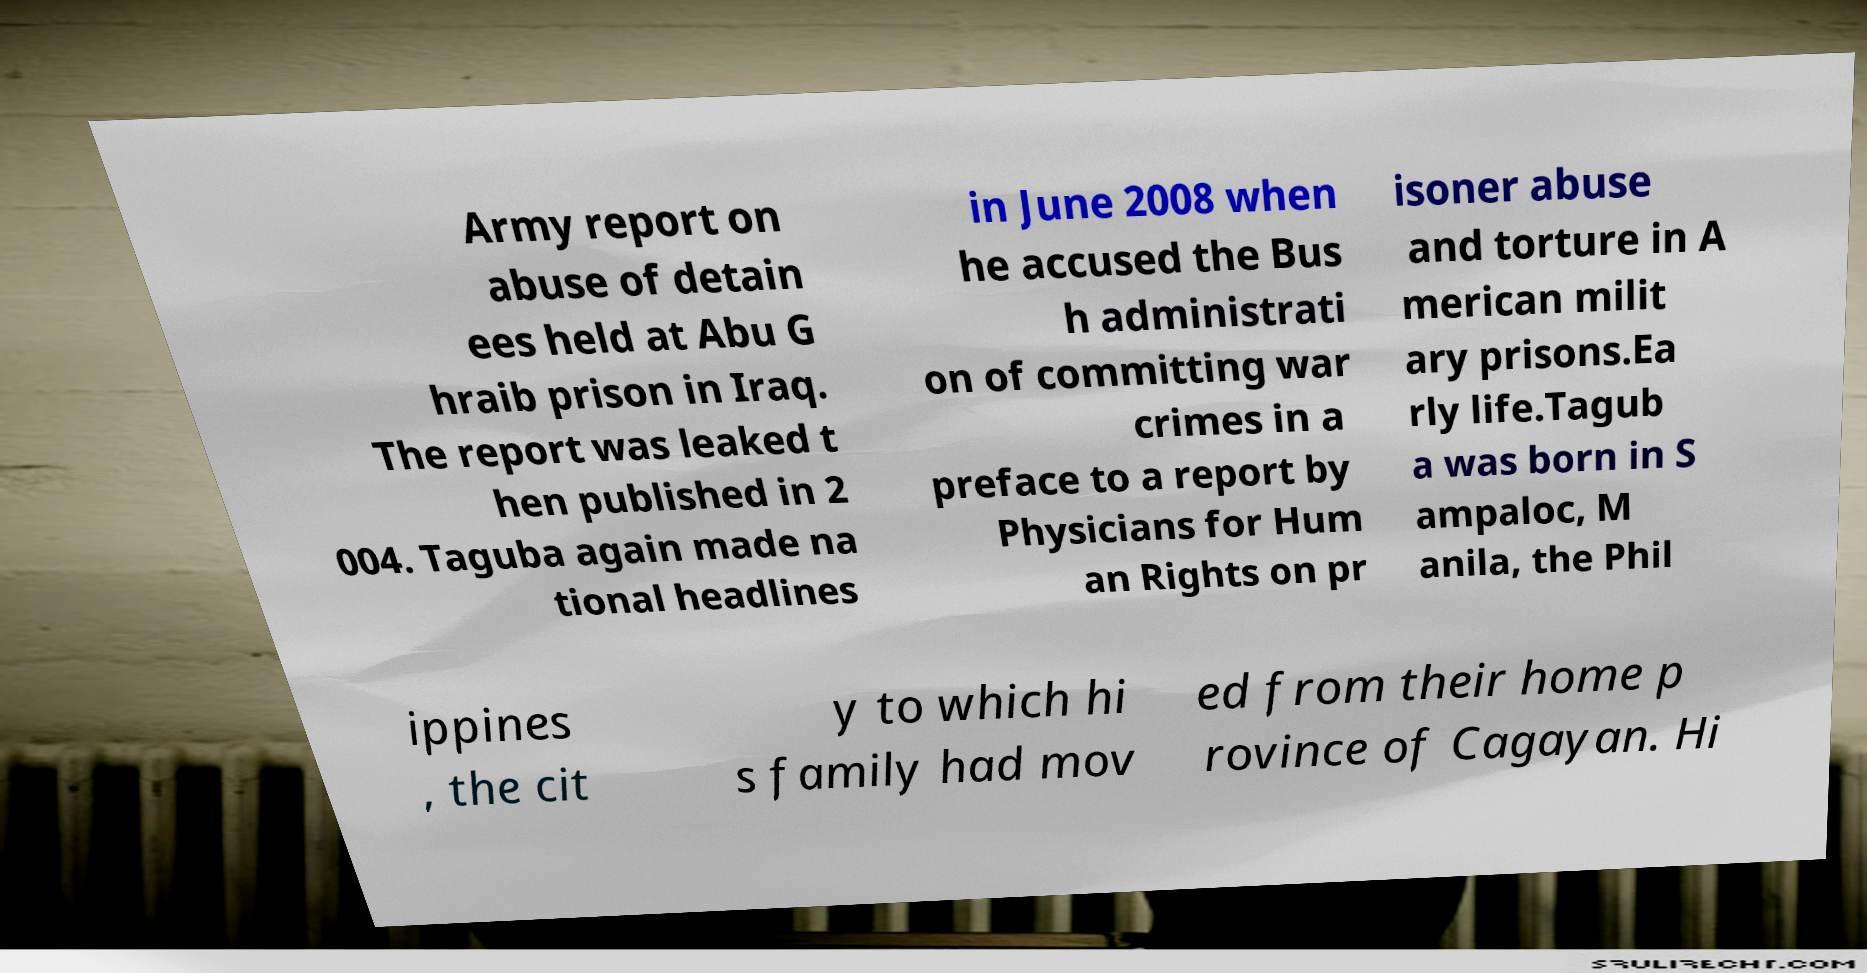Can you read and provide the text displayed in the image?This photo seems to have some interesting text. Can you extract and type it out for me? Army report on abuse of detain ees held at Abu G hraib prison in Iraq. The report was leaked t hen published in 2 004. Taguba again made na tional headlines in June 2008 when he accused the Bus h administrati on of committing war crimes in a preface to a report by Physicians for Hum an Rights on pr isoner abuse and torture in A merican milit ary prisons.Ea rly life.Tagub a was born in S ampaloc, M anila, the Phil ippines , the cit y to which hi s family had mov ed from their home p rovince of Cagayan. Hi 